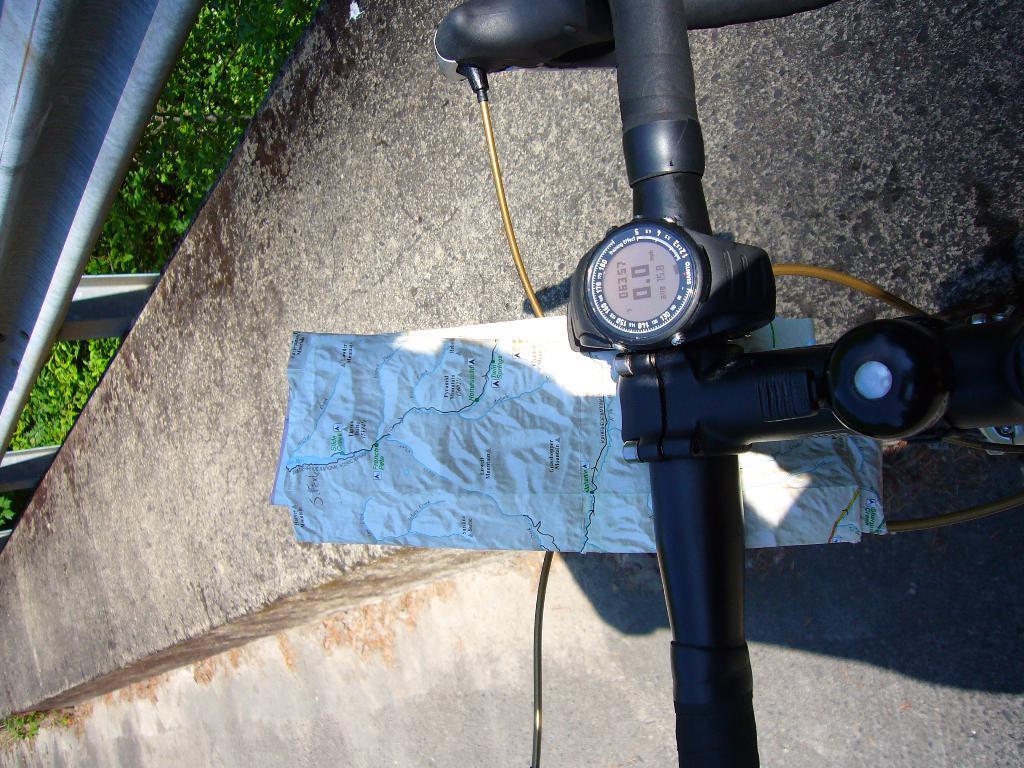Please provide a concise description of this image. In this image I can see the bicycle handle and the map. In the background I can see the railing and the plants. 